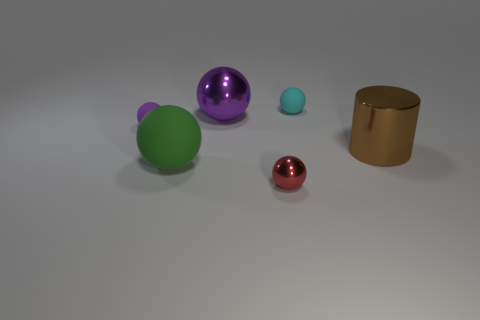Subtract all red balls. How many balls are left? 4 Subtract 1 spheres. How many spheres are left? 4 Subtract all small red balls. How many balls are left? 4 Subtract all gray balls. Subtract all cyan cylinders. How many balls are left? 5 Add 3 big cyan balls. How many objects exist? 9 Subtract all spheres. How many objects are left? 1 Add 2 cyan rubber balls. How many cyan rubber balls exist? 3 Subtract 0 cyan blocks. How many objects are left? 6 Subtract all cylinders. Subtract all purple metallic things. How many objects are left? 4 Add 5 purple rubber objects. How many purple rubber objects are left? 6 